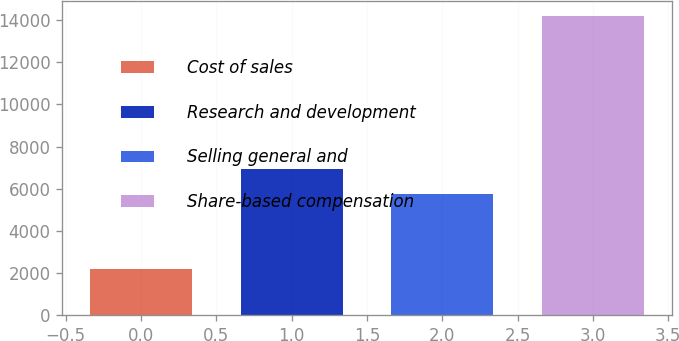Convert chart. <chart><loc_0><loc_0><loc_500><loc_500><bar_chart><fcel>Cost of sales<fcel>Research and development<fcel>Selling general and<fcel>Share-based compensation<nl><fcel>2174<fcel>6938.5<fcel>5734<fcel>14219<nl></chart> 